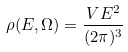Convert formula to latex. <formula><loc_0><loc_0><loc_500><loc_500>\rho ( E , \Omega ) = \frac { V E ^ { 2 } } { ( 2 \pi ) ^ { 3 } }</formula> 